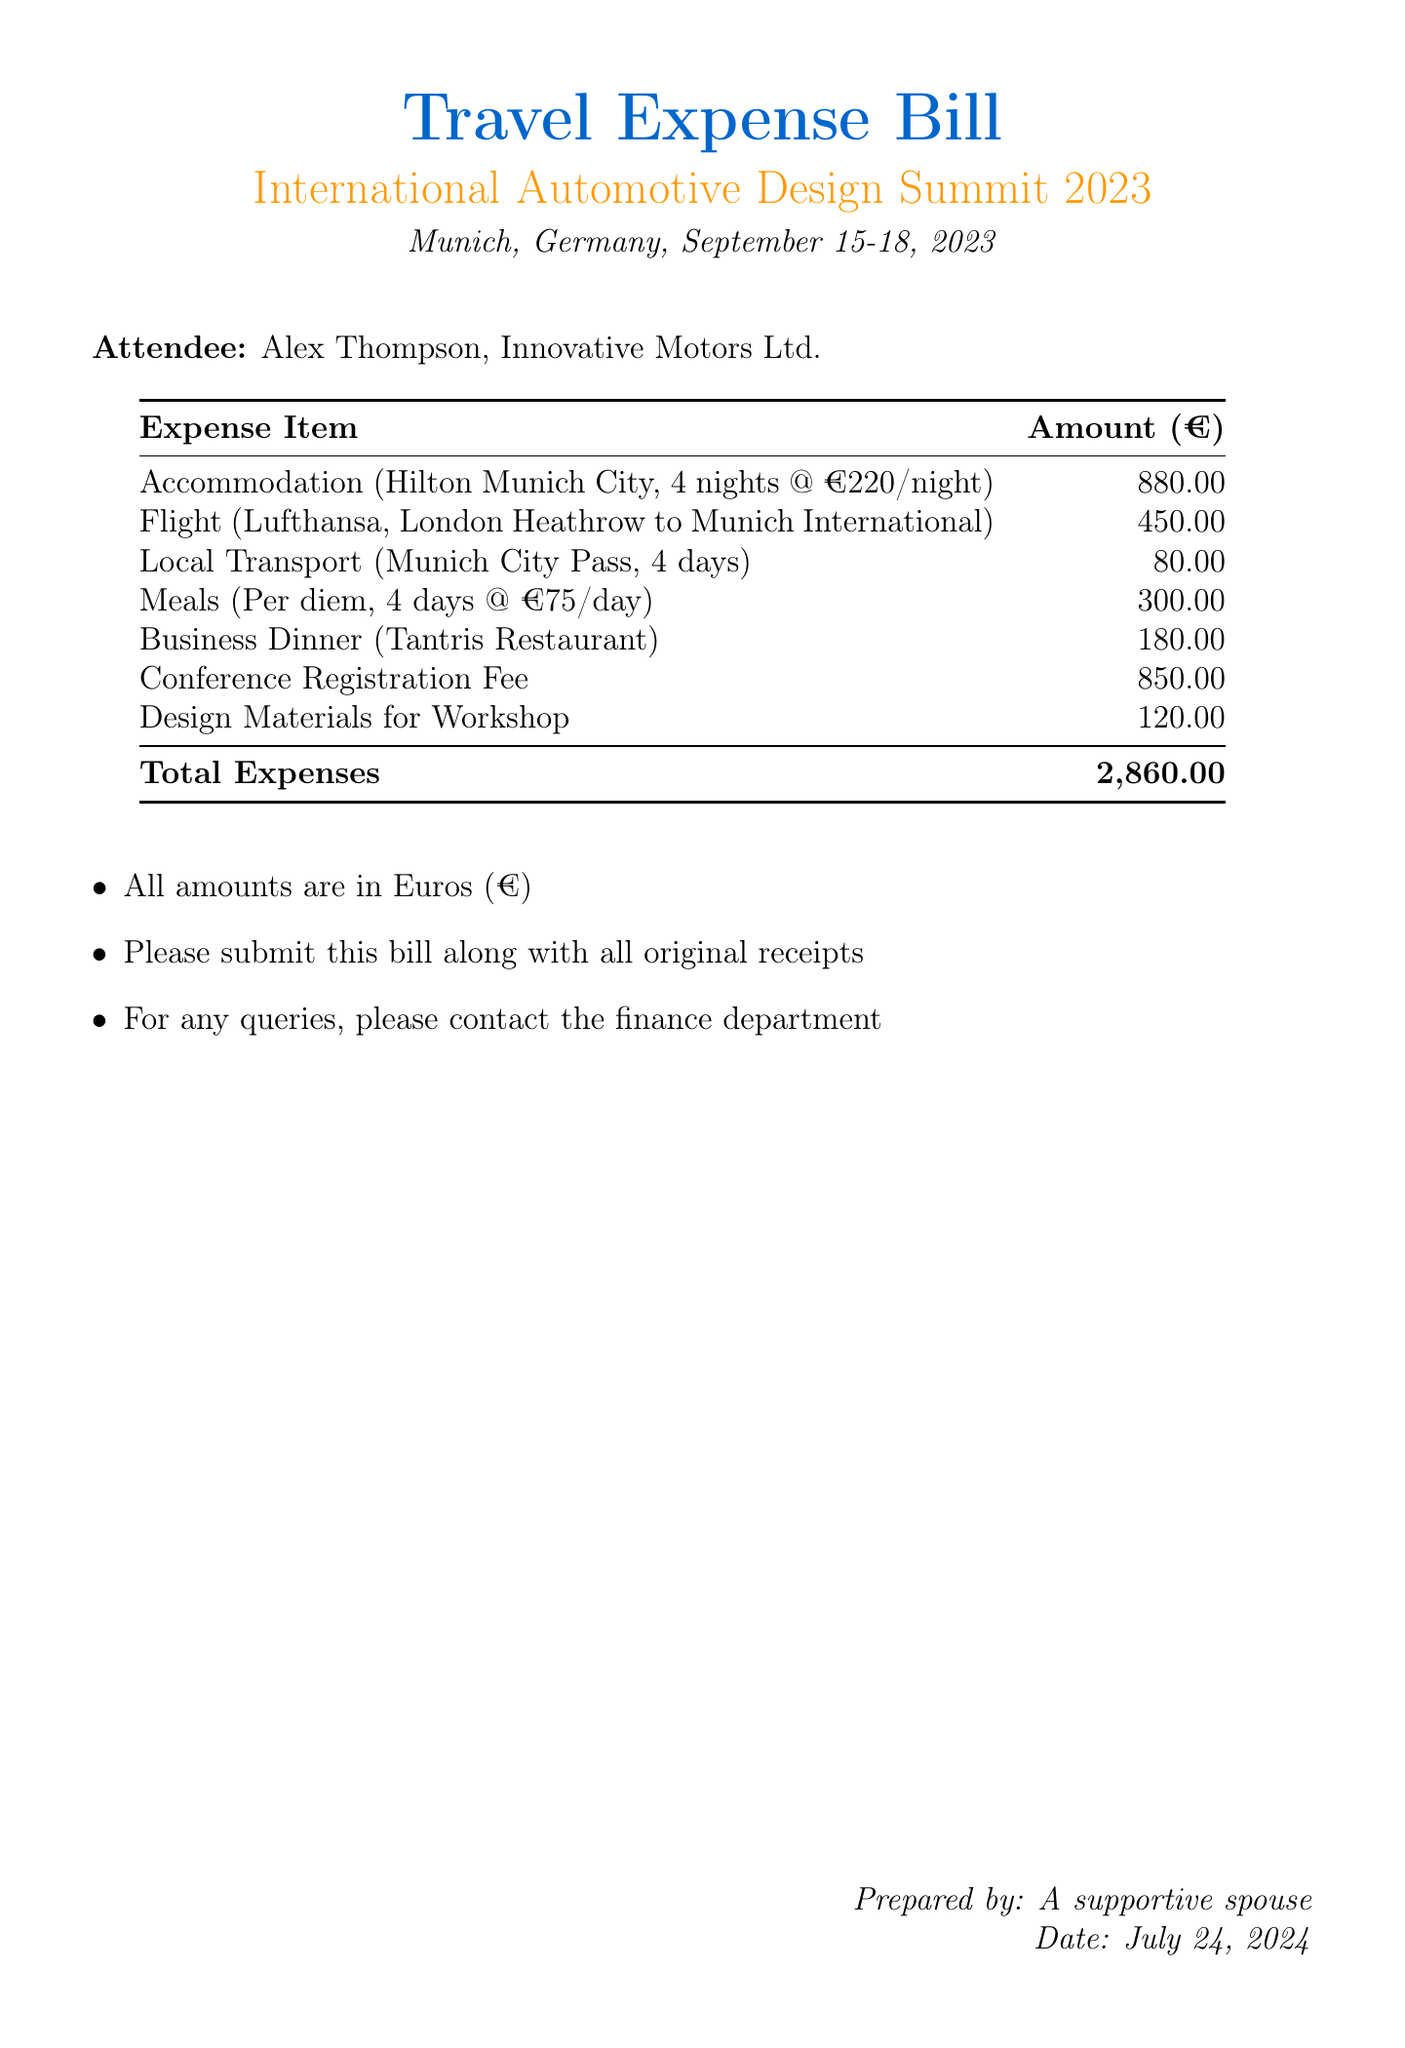What is the total amount of the travel expenses? The total amount is calculated by adding all the individual expenses listed in the bill.
Answer: 2,860.00 What is the accommodation cost per night? The accommodation cost is specified in the document as a cost per night for the duration of the stay.
Answer: 220.00 How many nights did Alex stay in the hotel? The document states the duration of the accommodation as four nights in total.
Answer: 4 Which restaurant was chosen for the business dinner? The document specifically names the restaurant where the business dinner took place.
Answer: Tantris Restaurant What is the cost of the conference registration fee? The conference registration fee is listed as a distinct expense in the document.
Answer: 850.00 What type of transport was used locally? The local transport expense is described in terms of a travel pass used during the stay in Munich.
Answer: Munich City Pass How much was spent on meals per day? The meals expense is indicated as a per diem rate for each day of attendance at the conference.
Answer: 75.00 What date did the conference take place? The document clearly specifies the dates for the conference's duration in September.
Answer: September 15-18, 2023 Who prepared the travel expense bill? The document includes the name of the individual who prepared the bill at the bottom.
Answer: A supportive spouse 